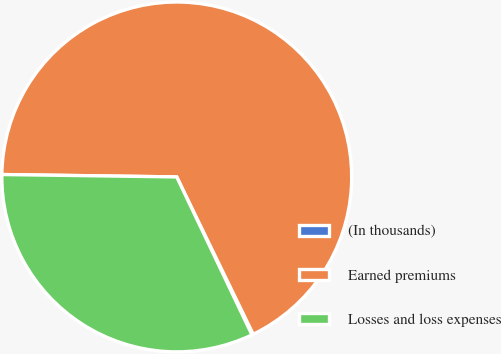Convert chart. <chart><loc_0><loc_0><loc_500><loc_500><pie_chart><fcel>(In thousands)<fcel>Earned premiums<fcel>Losses and loss expenses<nl><fcel>0.13%<fcel>67.58%<fcel>32.29%<nl></chart> 